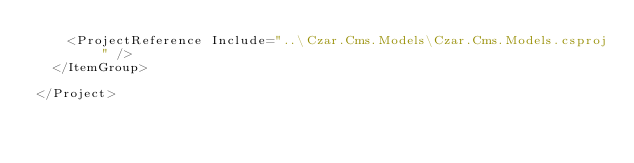<code> <loc_0><loc_0><loc_500><loc_500><_XML_>    <ProjectReference Include="..\Czar.Cms.Models\Czar.Cms.Models.csproj" />
  </ItemGroup>

</Project>
</code> 